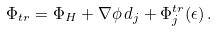Convert formula to latex. <formula><loc_0><loc_0><loc_500><loc_500>\Phi _ { t r } = \Phi _ { H } + \nabla \phi \, d _ { j } + \Phi _ { j } ^ { t r } ( \epsilon ) \, .</formula> 